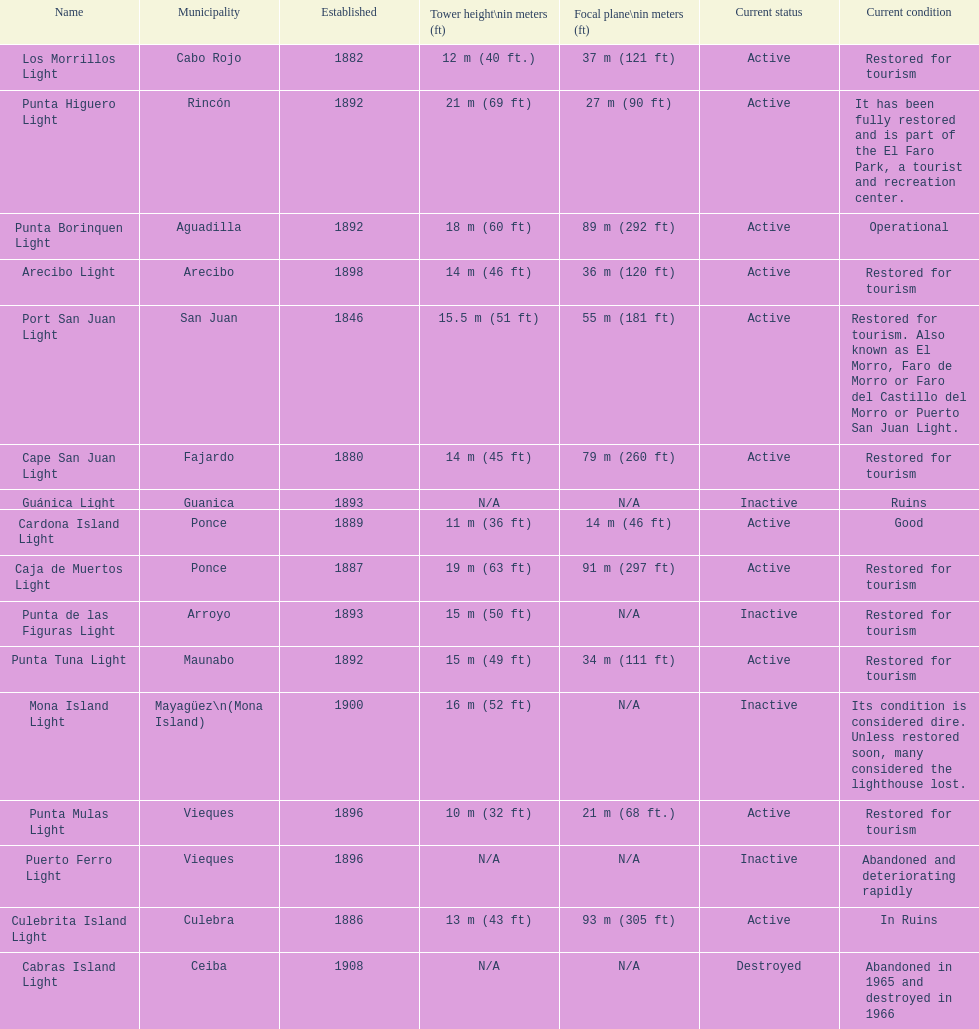Cardona island light and caja de muertos light are both located in what municipality? Ponce. 